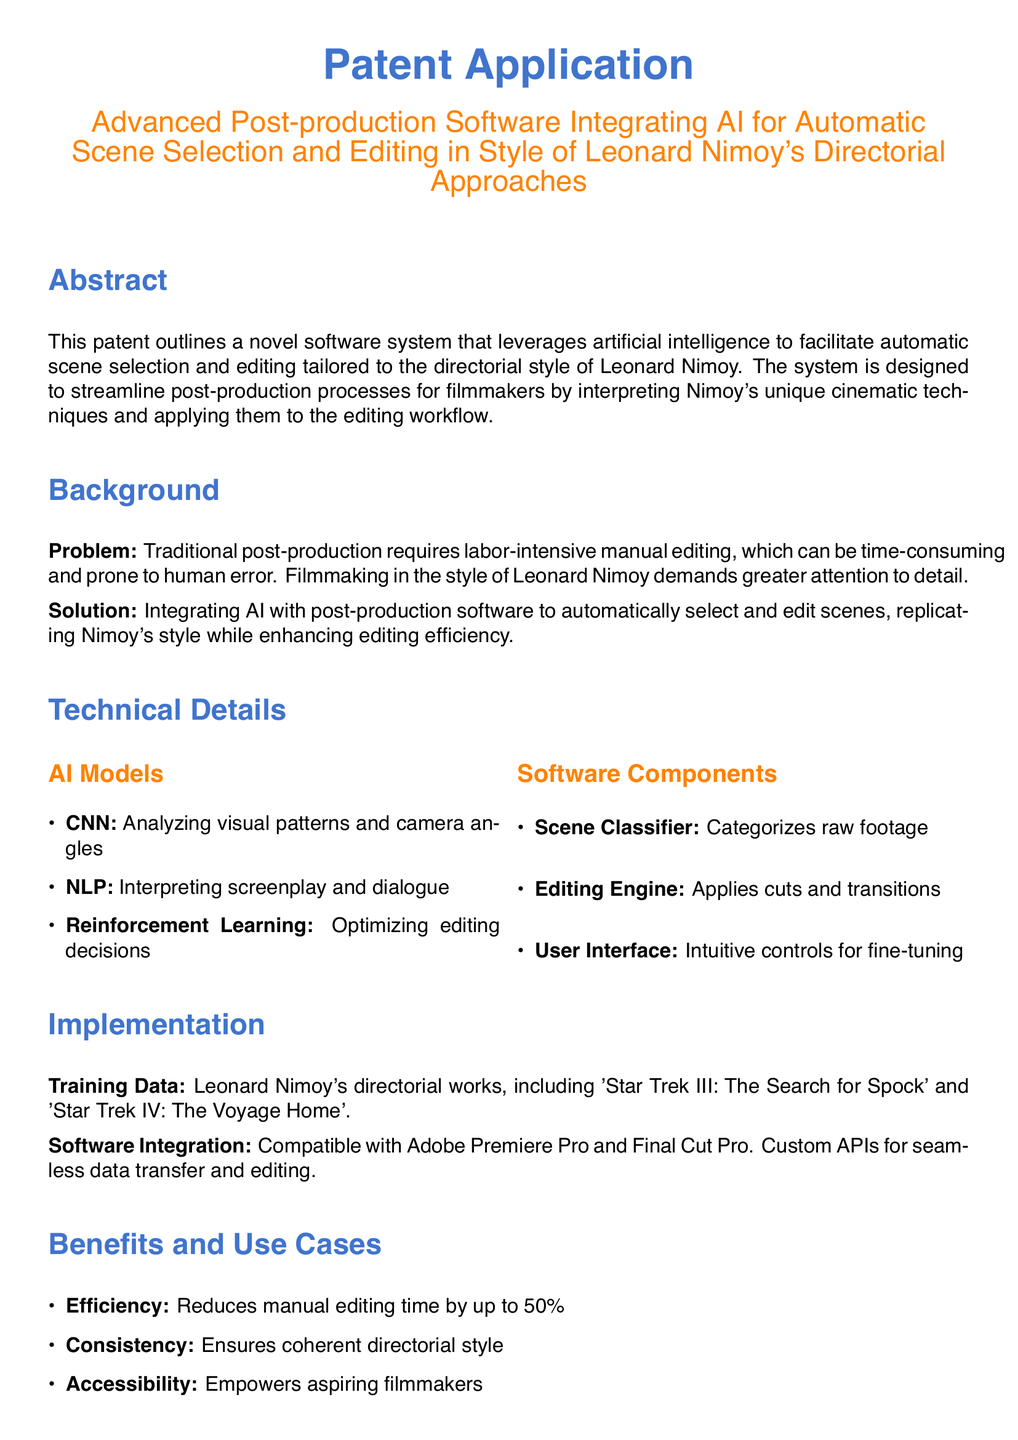What is the main focus of the patent application? The main focus of the patent application is the development of software for post-production that integrates AI for scene selection and editing.
Answer: Automatic scene selection and editing What unique directorial style does the software replicate? The software is designed to replicate the directorial style of Leonard Nimoy, as mentioned in the title and abstract.
Answer: Leonard Nimoy's What type of AI model is used for analyzing visual patterns? The AI model that analyzes visual patterns and camera angles is specified in the Technical Details section.
Answer: CNN How much can manual editing time be reduced by using this software? The document states a specific percentage reduction in manual editing time, found in the Benefits section.
Answer: 50% What existing software is this application compatible with? The Implementation section of the document mentions specific editing software that is integrated with this application.
Answer: Adobe Premiere Pro and Final Cut Pro What is the main problem addressed by this patent? The document highlights a significant issue in traditional post-production processes that motivate the creation of this software.
Answer: Labor-intensive manual editing Which directorial works were used for training data? The Implementation section lists specific films directed by Nimoy that served as training data for the AI models used in this software.
Answer: 'Star Trek III: The Search for Spock' and 'Star Trek IV: The Voyage Home' What benefit does this software provide for aspiring filmmakers? The Benefits section explicitly states how this technology impacts aspiring filmmakers in terms of accessibility.
Answer: Empowers aspiring filmmakers 